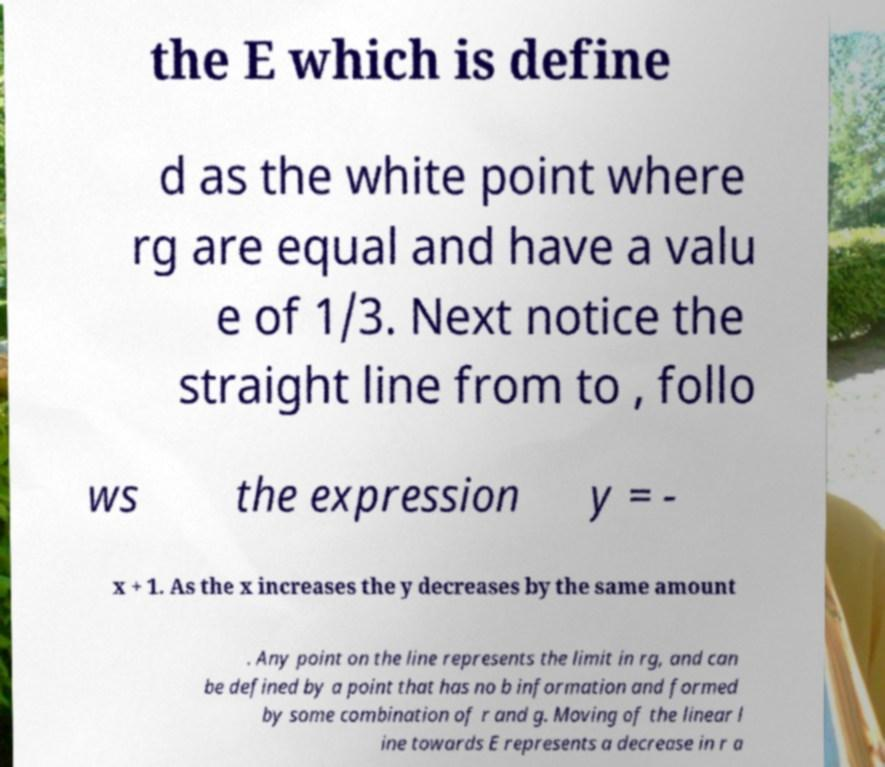Can you read and provide the text displayed in the image?This photo seems to have some interesting text. Can you extract and type it out for me? the E which is define d as the white point where rg are equal and have a valu e of 1/3. Next notice the straight line from to , follo ws the expression y = - x + 1. As the x increases the y decreases by the same amount . Any point on the line represents the limit in rg, and can be defined by a point that has no b information and formed by some combination of r and g. Moving of the linear l ine towards E represents a decrease in r a 